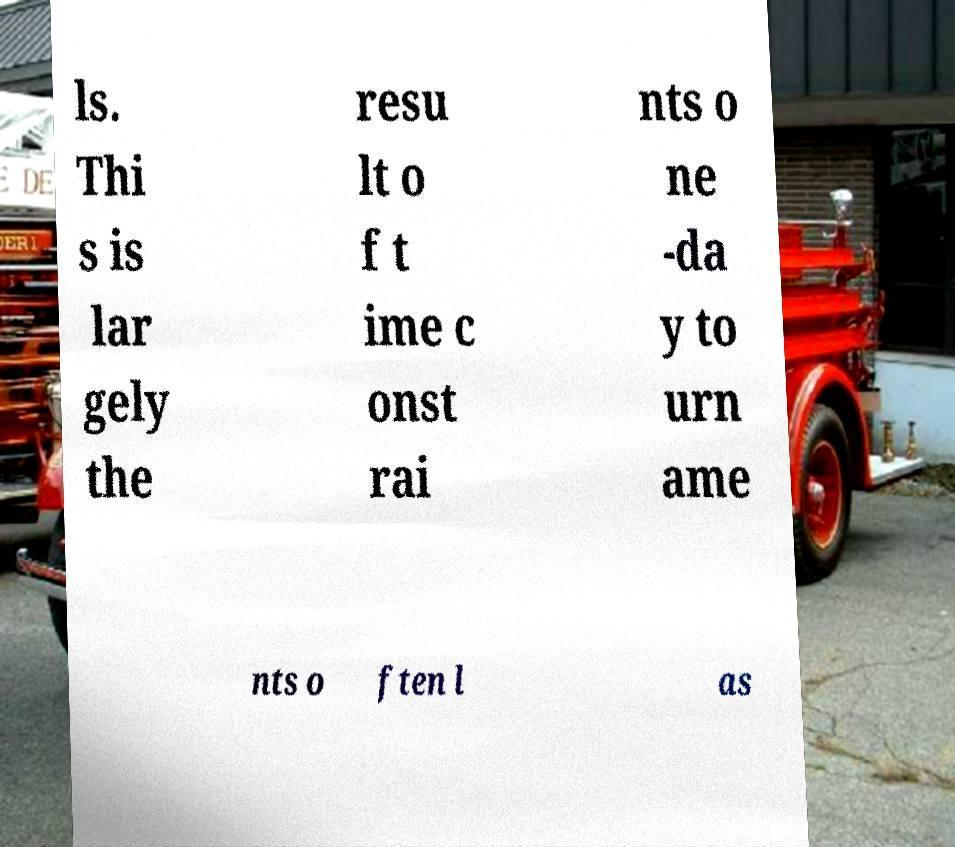Please read and relay the text visible in this image. What does it say? ls. Thi s is lar gely the resu lt o f t ime c onst rai nts o ne -da y to urn ame nts o ften l as 